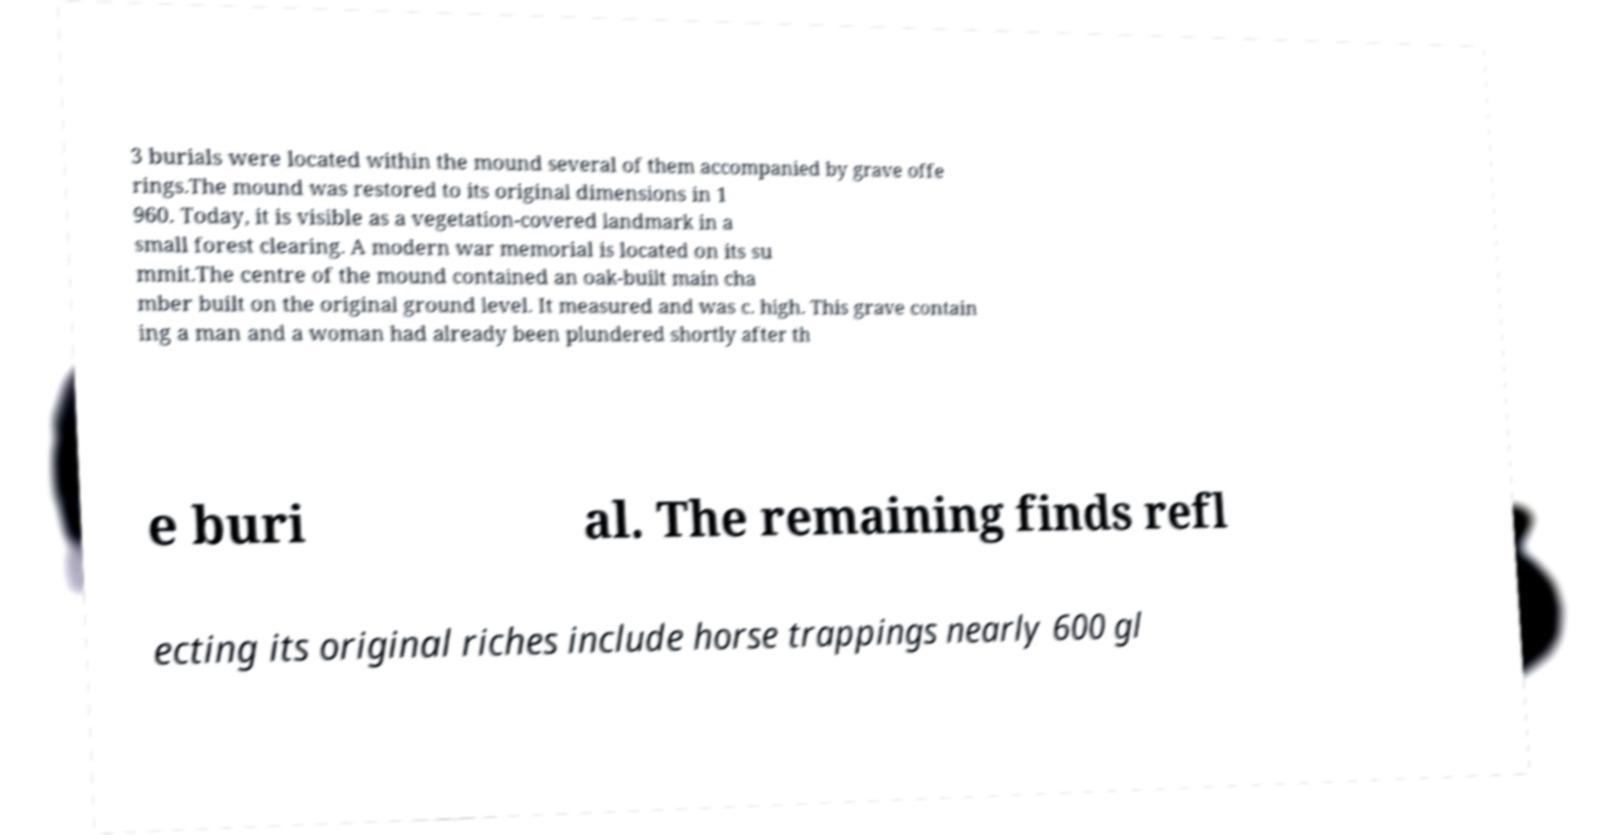I need the written content from this picture converted into text. Can you do that? 3 burials were located within the mound several of them accompanied by grave offe rings.The mound was restored to its original dimensions in 1 960. Today, it is visible as a vegetation-covered landmark in a small forest clearing. A modern war memorial is located on its su mmit.The centre of the mound contained an oak-built main cha mber built on the original ground level. It measured and was c. high. This grave contain ing a man and a woman had already been plundered shortly after th e buri al. The remaining finds refl ecting its original riches include horse trappings nearly 600 gl 